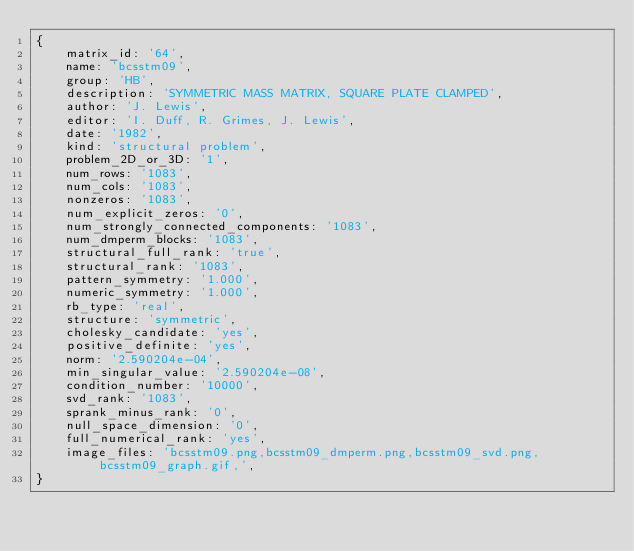Convert code to text. <code><loc_0><loc_0><loc_500><loc_500><_Ruby_>{
    matrix_id: '64',
    name: 'bcsstm09',
    group: 'HB',
    description: 'SYMMETRIC MASS MATRIX, SQUARE PLATE CLAMPED',
    author: 'J. Lewis',
    editor: 'I. Duff, R. Grimes, J. Lewis',
    date: '1982',
    kind: 'structural problem',
    problem_2D_or_3D: '1',
    num_rows: '1083',
    num_cols: '1083',
    nonzeros: '1083',
    num_explicit_zeros: '0',
    num_strongly_connected_components: '1083',
    num_dmperm_blocks: '1083',
    structural_full_rank: 'true',
    structural_rank: '1083',
    pattern_symmetry: '1.000',
    numeric_symmetry: '1.000',
    rb_type: 'real',
    structure: 'symmetric',
    cholesky_candidate: 'yes',
    positive_definite: 'yes',
    norm: '2.590204e-04',
    min_singular_value: '2.590204e-08',
    condition_number: '10000',
    svd_rank: '1083',
    sprank_minus_rank: '0',
    null_space_dimension: '0',
    full_numerical_rank: 'yes',
    image_files: 'bcsstm09.png,bcsstm09_dmperm.png,bcsstm09_svd.png,bcsstm09_graph.gif,',
}
</code> 